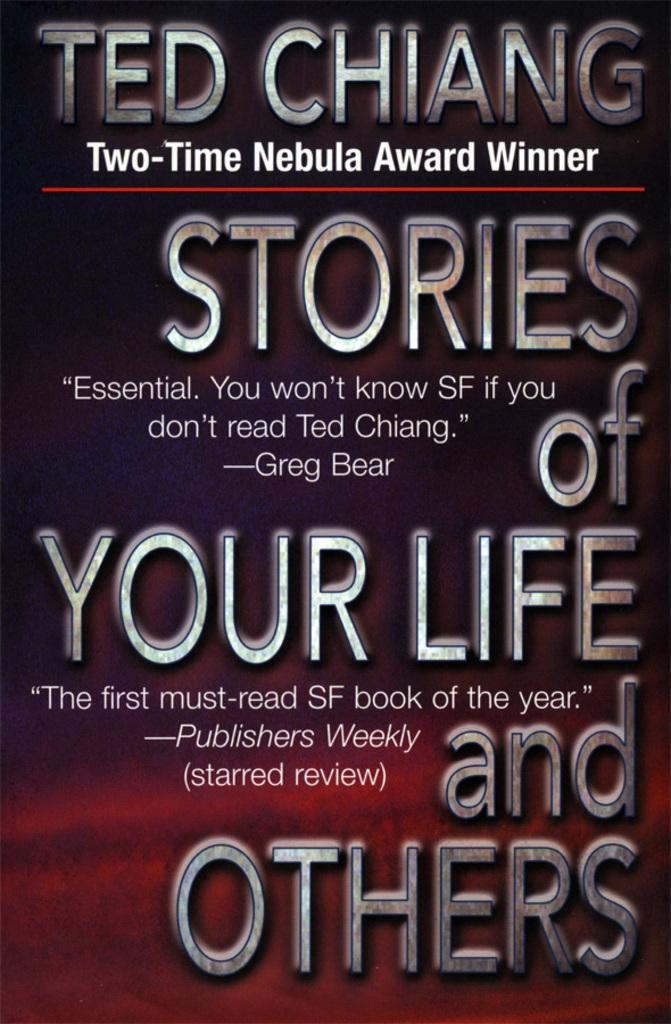<image>
Create a compact narrative representing the image presented. a book that says 'ted chiang two-time nebula award winner' onit 